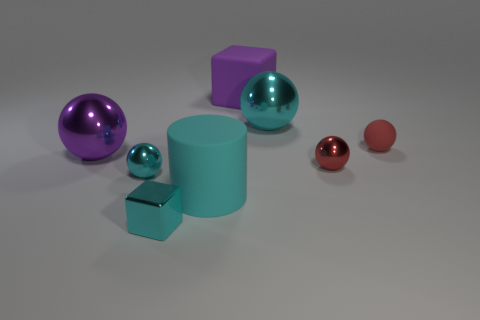Subtract all red spheres. How many were subtracted if there are1red spheres left? 1 Subtract 1 balls. How many balls are left? 4 Subtract all purple balls. How many balls are left? 4 Subtract all blue balls. Subtract all blue cylinders. How many balls are left? 5 Add 2 cylinders. How many objects exist? 10 Subtract all spheres. How many objects are left? 3 Subtract 1 purple cubes. How many objects are left? 7 Subtract all big cyan rubber cylinders. Subtract all cyan matte cylinders. How many objects are left? 6 Add 4 purple rubber cubes. How many purple rubber cubes are left? 5 Add 6 big rubber objects. How many big rubber objects exist? 8 